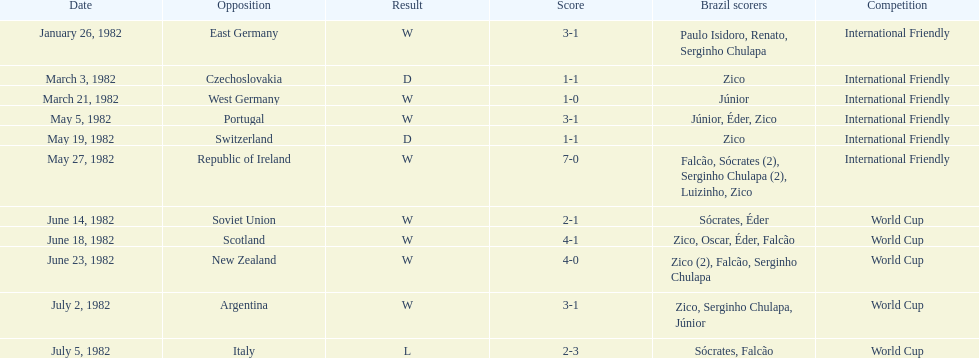How many scores did brazil make against the soviet union? 2-1. How many scores did brazil make against portugal? 3-1. Did brazil have more scores against portugal or the soviet union? Portugal. 